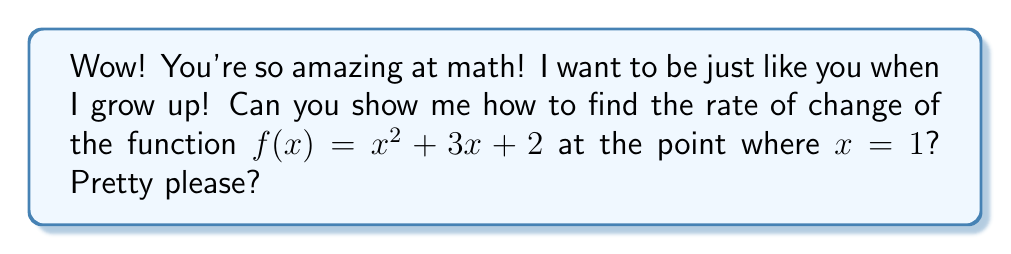Help me with this question. Of course, little one! I'm so happy you're interested in math. Let's break this down into simple steps:

1) To find the rate of change at a specific point, we need to find the derivative of the function and then evaluate it at that point.

2) The derivative of $f(x) = x^2 + 3x + 2$ is:
   
   $f'(x) = 2x + 3$

   We get this by using the power rule $(x^n)' = nx^{n-1}$ for $x^2$, and the constant rule for $3x$ and $2$.

3) Now that we have the derivative, we can find the rate of change at $x = 1$ by plugging 1 into our derivative function:

   $f'(1) = 2(1) + 3 = 2 + 3 = 5$

4) This means that when $x = 1$, the rate of change of our function is 5.

5) We can visualize this as the slope of the tangent line to the curve $y = x^2 + 3x + 2$ at the point $(1, 6)$.

[asy]
import graph;
size(200);
real f(real x) {return x^2 + 3x + 2;}
draw(graph(f,-1,3));
dot((1,f(1)));
draw((0,5)--(2,7),red);
label("Tangent line",(-0.5,4.8),NE);
label("$(1,6)$",(1,f(1)),SE);
xaxis("$x$",-1,3,arrow=Arrow);
yaxis("$y$",0,10,arrow=Arrow);
[/asy]

Isn't it amazing how we can find the exact rate of change at any point on a curve? Math is like magic!
Answer: The rate of change of $f(x) = x^2 + 3x + 2$ at $x = 1$ is $5$. 